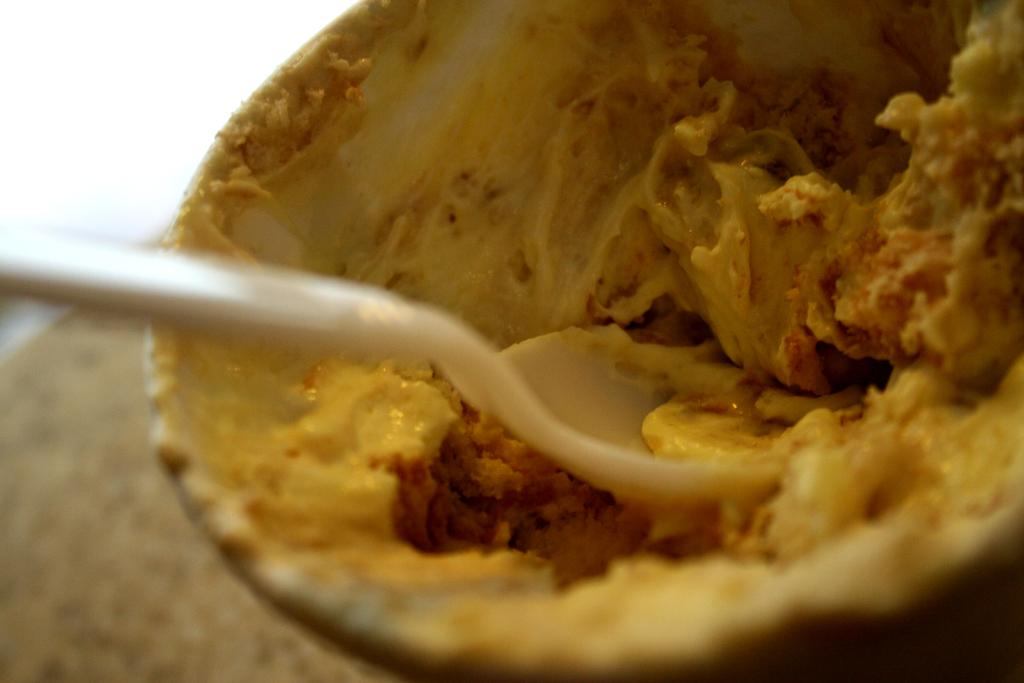What is in the image that can hold food? There is a bowl in the image that can hold food. What type of food is in the bowl? The bowl contains food, but the specific type of food is not mentioned in the facts. What utensil is present in the image? There is a spoon in the image. What type of can is depicted in the image? There is no can present in the image. 